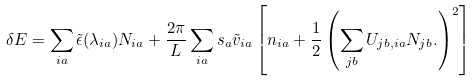Convert formula to latex. <formula><loc_0><loc_0><loc_500><loc_500>\delta E = \sum _ { i a } \tilde { \epsilon } ( \lambda _ { i a } ) N _ { i a } + \frac { 2 \pi } { L } \sum _ { i a } s _ { a } \tilde { v } _ { i a } \left [ n _ { i a } + \frac { 1 } { 2 } \left ( \sum _ { j b } U _ { j b , i a } N _ { j b } . \right ) ^ { 2 } \right ]</formula> 